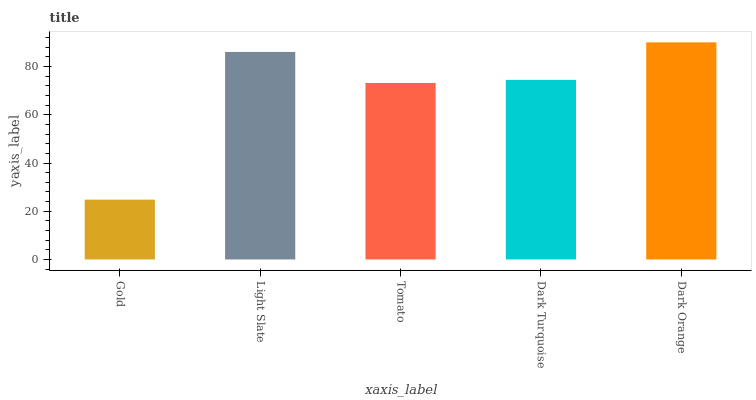Is Gold the minimum?
Answer yes or no. Yes. Is Dark Orange the maximum?
Answer yes or no. Yes. Is Light Slate the minimum?
Answer yes or no. No. Is Light Slate the maximum?
Answer yes or no. No. Is Light Slate greater than Gold?
Answer yes or no. Yes. Is Gold less than Light Slate?
Answer yes or no. Yes. Is Gold greater than Light Slate?
Answer yes or no. No. Is Light Slate less than Gold?
Answer yes or no. No. Is Dark Turquoise the high median?
Answer yes or no. Yes. Is Dark Turquoise the low median?
Answer yes or no. Yes. Is Light Slate the high median?
Answer yes or no. No. Is Light Slate the low median?
Answer yes or no. No. 